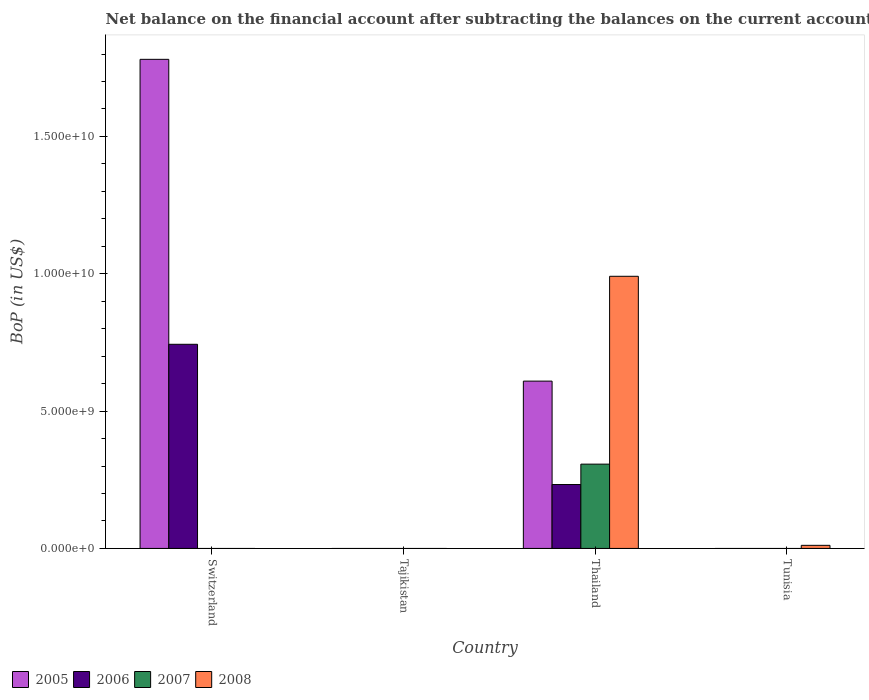Are the number of bars on each tick of the X-axis equal?
Make the answer very short. No. How many bars are there on the 1st tick from the right?
Keep it short and to the point. 1. What is the label of the 2nd group of bars from the left?
Offer a terse response. Tajikistan. In how many cases, is the number of bars for a given country not equal to the number of legend labels?
Ensure brevity in your answer.  3. What is the Balance of Payments in 2008 in Tunisia?
Offer a very short reply. 1.13e+08. Across all countries, what is the maximum Balance of Payments in 2005?
Your response must be concise. 1.78e+1. In which country was the Balance of Payments in 2007 maximum?
Provide a short and direct response. Thailand. What is the total Balance of Payments in 2008 in the graph?
Give a very brief answer. 1.00e+1. What is the difference between the Balance of Payments in 2005 in Tajikistan and the Balance of Payments in 2008 in Tunisia?
Your answer should be compact. -1.13e+08. What is the average Balance of Payments in 2005 per country?
Make the answer very short. 5.97e+09. What is the difference between the Balance of Payments of/in 2007 and Balance of Payments of/in 2008 in Thailand?
Your answer should be very brief. -6.84e+09. What is the difference between the highest and the lowest Balance of Payments in 2008?
Ensure brevity in your answer.  9.91e+09. In how many countries, is the Balance of Payments in 2005 greater than the average Balance of Payments in 2005 taken over all countries?
Make the answer very short. 2. Is the sum of the Balance of Payments in 2005 in Switzerland and Thailand greater than the maximum Balance of Payments in 2007 across all countries?
Your response must be concise. Yes. Is it the case that in every country, the sum of the Balance of Payments in 2005 and Balance of Payments in 2006 is greater than the sum of Balance of Payments in 2008 and Balance of Payments in 2007?
Keep it short and to the point. No. Is it the case that in every country, the sum of the Balance of Payments in 2006 and Balance of Payments in 2007 is greater than the Balance of Payments in 2008?
Offer a terse response. No. How many bars are there?
Your answer should be compact. 7. How many countries are there in the graph?
Offer a very short reply. 4. What is the difference between two consecutive major ticks on the Y-axis?
Make the answer very short. 5.00e+09. Does the graph contain any zero values?
Your answer should be compact. Yes. Where does the legend appear in the graph?
Your answer should be very brief. Bottom left. What is the title of the graph?
Offer a very short reply. Net balance on the financial account after subtracting the balances on the current accounts. What is the label or title of the Y-axis?
Offer a terse response. BoP (in US$). What is the BoP (in US$) of 2005 in Switzerland?
Offer a terse response. 1.78e+1. What is the BoP (in US$) in 2006 in Switzerland?
Your answer should be compact. 7.43e+09. What is the BoP (in US$) in 2007 in Switzerland?
Keep it short and to the point. 0. What is the BoP (in US$) of 2008 in Switzerland?
Keep it short and to the point. 0. What is the BoP (in US$) in 2006 in Tajikistan?
Keep it short and to the point. 0. What is the BoP (in US$) in 2005 in Thailand?
Your answer should be compact. 6.09e+09. What is the BoP (in US$) of 2006 in Thailand?
Your answer should be very brief. 2.33e+09. What is the BoP (in US$) in 2007 in Thailand?
Give a very brief answer. 3.07e+09. What is the BoP (in US$) of 2008 in Thailand?
Provide a succinct answer. 9.91e+09. What is the BoP (in US$) of 2006 in Tunisia?
Your answer should be very brief. 0. What is the BoP (in US$) of 2007 in Tunisia?
Offer a terse response. 0. What is the BoP (in US$) in 2008 in Tunisia?
Keep it short and to the point. 1.13e+08. Across all countries, what is the maximum BoP (in US$) of 2005?
Provide a succinct answer. 1.78e+1. Across all countries, what is the maximum BoP (in US$) of 2006?
Ensure brevity in your answer.  7.43e+09. Across all countries, what is the maximum BoP (in US$) of 2007?
Keep it short and to the point. 3.07e+09. Across all countries, what is the maximum BoP (in US$) of 2008?
Give a very brief answer. 9.91e+09. Across all countries, what is the minimum BoP (in US$) in 2006?
Offer a very short reply. 0. What is the total BoP (in US$) of 2005 in the graph?
Ensure brevity in your answer.  2.39e+1. What is the total BoP (in US$) of 2006 in the graph?
Your answer should be very brief. 9.76e+09. What is the total BoP (in US$) in 2007 in the graph?
Offer a very short reply. 3.07e+09. What is the total BoP (in US$) in 2008 in the graph?
Your answer should be compact. 1.00e+1. What is the difference between the BoP (in US$) in 2005 in Switzerland and that in Thailand?
Provide a short and direct response. 1.17e+1. What is the difference between the BoP (in US$) in 2006 in Switzerland and that in Thailand?
Offer a terse response. 5.11e+09. What is the difference between the BoP (in US$) in 2008 in Thailand and that in Tunisia?
Keep it short and to the point. 9.80e+09. What is the difference between the BoP (in US$) in 2005 in Switzerland and the BoP (in US$) in 2006 in Thailand?
Make the answer very short. 1.55e+1. What is the difference between the BoP (in US$) of 2005 in Switzerland and the BoP (in US$) of 2007 in Thailand?
Provide a short and direct response. 1.47e+1. What is the difference between the BoP (in US$) in 2005 in Switzerland and the BoP (in US$) in 2008 in Thailand?
Provide a short and direct response. 7.90e+09. What is the difference between the BoP (in US$) in 2006 in Switzerland and the BoP (in US$) in 2007 in Thailand?
Your answer should be very brief. 4.36e+09. What is the difference between the BoP (in US$) in 2006 in Switzerland and the BoP (in US$) in 2008 in Thailand?
Make the answer very short. -2.48e+09. What is the difference between the BoP (in US$) in 2005 in Switzerland and the BoP (in US$) in 2008 in Tunisia?
Provide a short and direct response. 1.77e+1. What is the difference between the BoP (in US$) in 2006 in Switzerland and the BoP (in US$) in 2008 in Tunisia?
Provide a succinct answer. 7.32e+09. What is the difference between the BoP (in US$) in 2005 in Thailand and the BoP (in US$) in 2008 in Tunisia?
Provide a short and direct response. 5.98e+09. What is the difference between the BoP (in US$) in 2006 in Thailand and the BoP (in US$) in 2008 in Tunisia?
Make the answer very short. 2.21e+09. What is the difference between the BoP (in US$) of 2007 in Thailand and the BoP (in US$) of 2008 in Tunisia?
Your answer should be compact. 2.96e+09. What is the average BoP (in US$) in 2005 per country?
Keep it short and to the point. 5.97e+09. What is the average BoP (in US$) in 2006 per country?
Provide a succinct answer. 2.44e+09. What is the average BoP (in US$) of 2007 per country?
Offer a terse response. 7.67e+08. What is the average BoP (in US$) in 2008 per country?
Ensure brevity in your answer.  2.51e+09. What is the difference between the BoP (in US$) of 2005 and BoP (in US$) of 2006 in Switzerland?
Offer a terse response. 1.04e+1. What is the difference between the BoP (in US$) of 2005 and BoP (in US$) of 2006 in Thailand?
Ensure brevity in your answer.  3.76e+09. What is the difference between the BoP (in US$) of 2005 and BoP (in US$) of 2007 in Thailand?
Offer a very short reply. 3.02e+09. What is the difference between the BoP (in US$) in 2005 and BoP (in US$) in 2008 in Thailand?
Your answer should be compact. -3.82e+09. What is the difference between the BoP (in US$) of 2006 and BoP (in US$) of 2007 in Thailand?
Your answer should be very brief. -7.42e+08. What is the difference between the BoP (in US$) of 2006 and BoP (in US$) of 2008 in Thailand?
Your answer should be compact. -7.58e+09. What is the difference between the BoP (in US$) in 2007 and BoP (in US$) in 2008 in Thailand?
Give a very brief answer. -6.84e+09. What is the ratio of the BoP (in US$) in 2005 in Switzerland to that in Thailand?
Your answer should be very brief. 2.92. What is the ratio of the BoP (in US$) of 2006 in Switzerland to that in Thailand?
Your answer should be compact. 3.19. What is the ratio of the BoP (in US$) in 2008 in Thailand to that in Tunisia?
Make the answer very short. 87.9. What is the difference between the highest and the lowest BoP (in US$) in 2005?
Your answer should be compact. 1.78e+1. What is the difference between the highest and the lowest BoP (in US$) of 2006?
Provide a short and direct response. 7.43e+09. What is the difference between the highest and the lowest BoP (in US$) of 2007?
Provide a short and direct response. 3.07e+09. What is the difference between the highest and the lowest BoP (in US$) in 2008?
Your answer should be very brief. 9.91e+09. 